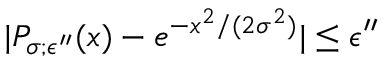<formula> <loc_0><loc_0><loc_500><loc_500>| P _ { \sigma ; \epsilon ^ { \prime \prime } } ( x ) - e ^ { - x ^ { 2 } / ( 2 \sigma ^ { 2 } ) } | \leq \epsilon ^ { \prime \prime }</formula> 